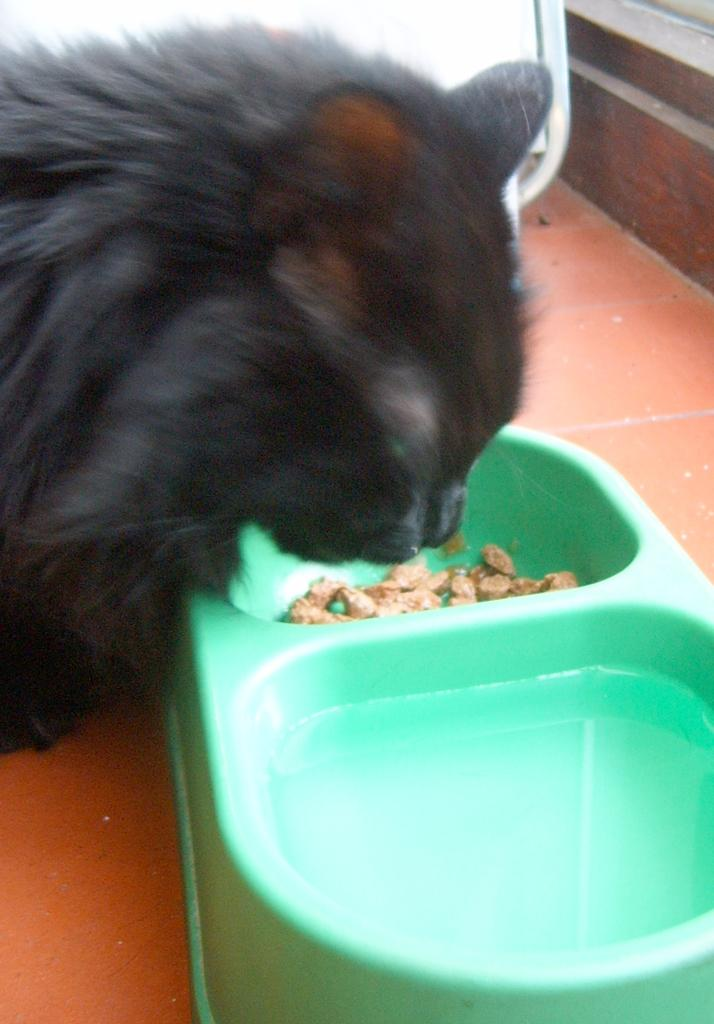What type of animal is in the image? There is a black color cat in the image. What is the cat doing in the image? The cat is eating something. What object is present in the image that the cat might be eating from? There is a plastic bowl in the image. What color is the plastic bowl? The plastic bowl is green in color. Can you see the badge on the cat's collar in the image? There is no mention of a collar or badge in the provided facts, so we cannot determine if the cat has a badge on its collar in the image. 